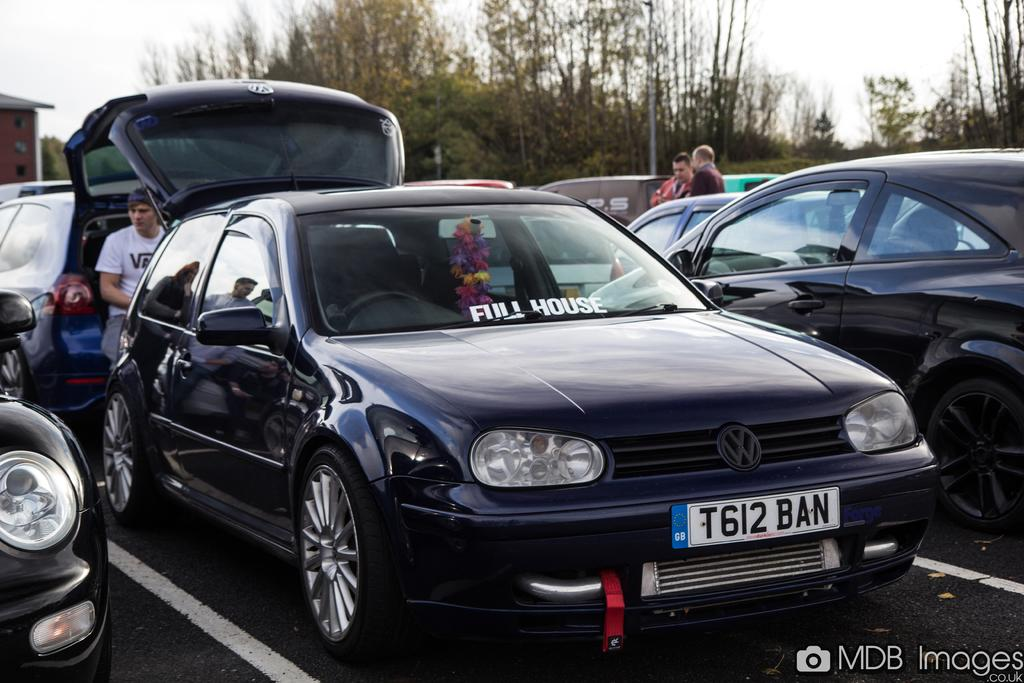What types of objects can be seen in the image? There are vehicles in the image. What are the people in the image doing? There are persons standing and one person sitting in the image. What can be seen in the background of the image? There are trees and a house in the background of the image. What is the condition of the sky in the image? The sky is cloudy in the image. What type of hair can be seen on the person sitting in the image? There is no information about the person's hair in the image, as the focus is on their sitting position. Is there any snow visible in the image? There is no mention of snow in the image, and the presence of a cloudy sky does not necessarily indicate snow. 